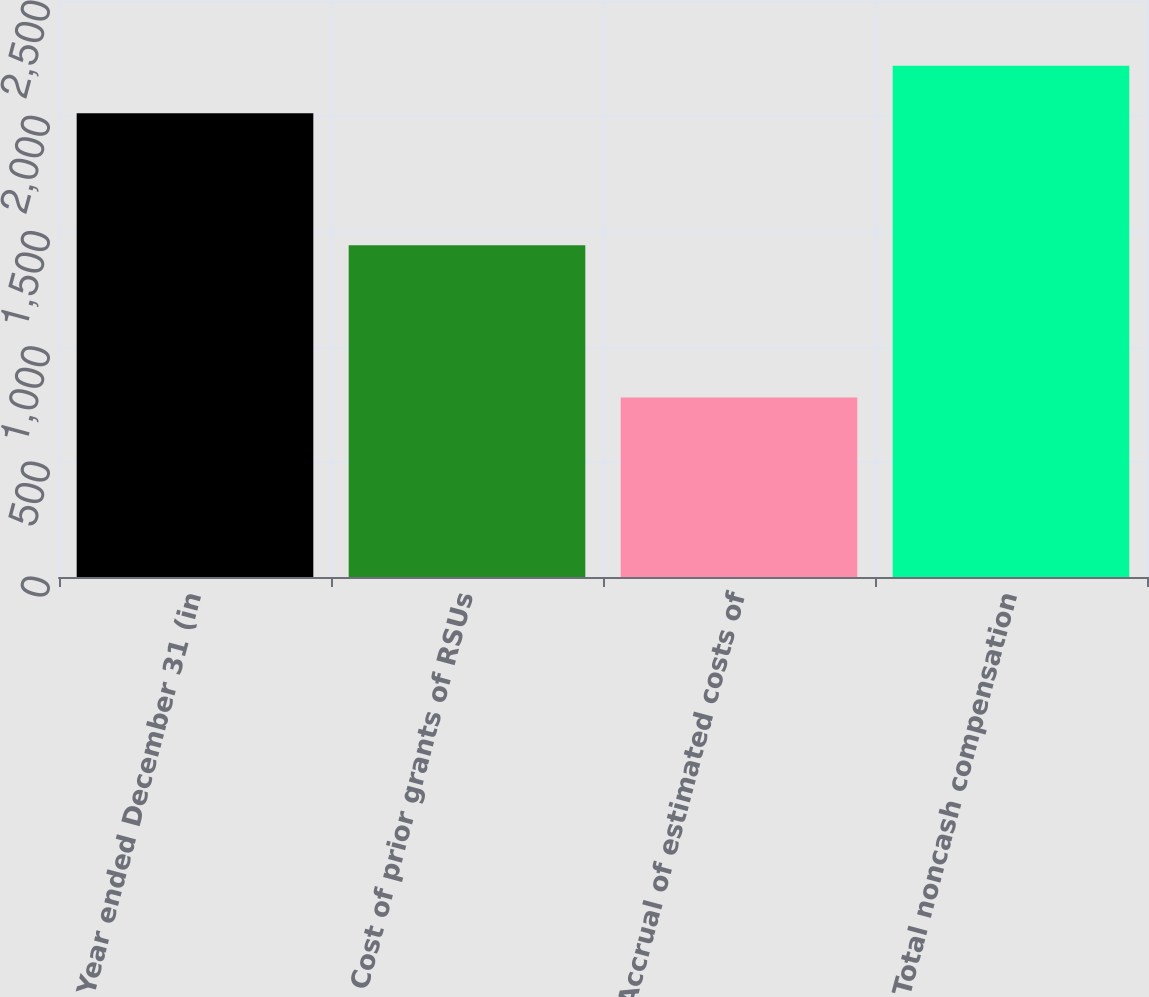Convert chart. <chart><loc_0><loc_0><loc_500><loc_500><bar_chart><fcel>Year ended December 31 (in<fcel>Cost of prior grants of RSUs<fcel>Accrual of estimated costs of<fcel>Total noncash compensation<nl><fcel>2013<fcel>1440<fcel>779<fcel>2219<nl></chart> 